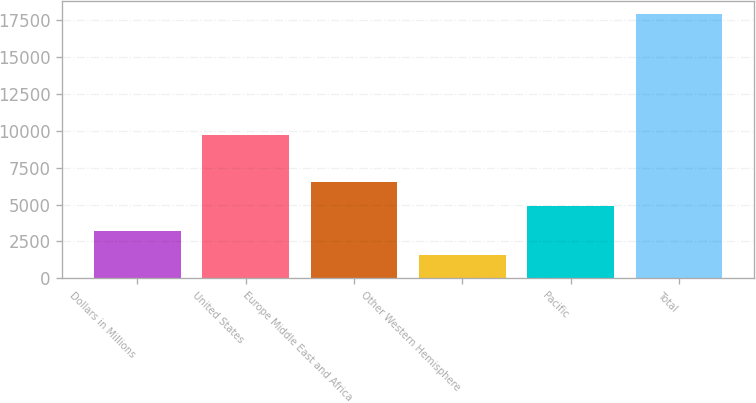<chart> <loc_0><loc_0><loc_500><loc_500><bar_chart><fcel>Dollars in Millions<fcel>United States<fcel>Europe Middle East and Africa<fcel>Other Western Hemisphere<fcel>Pacific<fcel>Total<nl><fcel>3244.9<fcel>9729<fcel>6504.7<fcel>1615<fcel>4874.8<fcel>17914<nl></chart> 